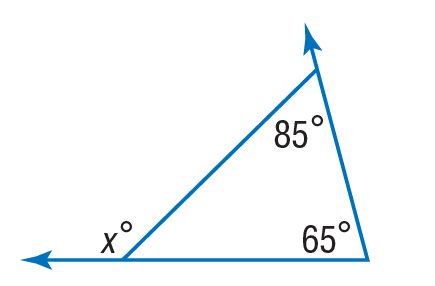Question: Find x to the nearest tenth.
Choices:
A. 20
B. 65
C. 85
D. 150
Answer with the letter. Answer: D 